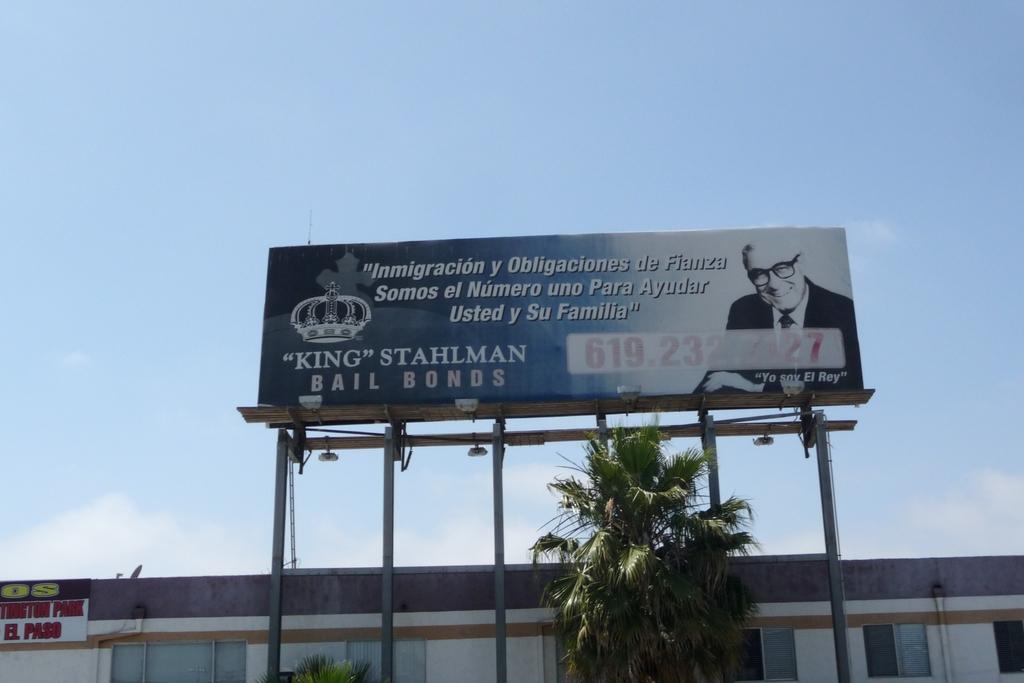Who is that in the sign?
Make the answer very short. King stahlman. 